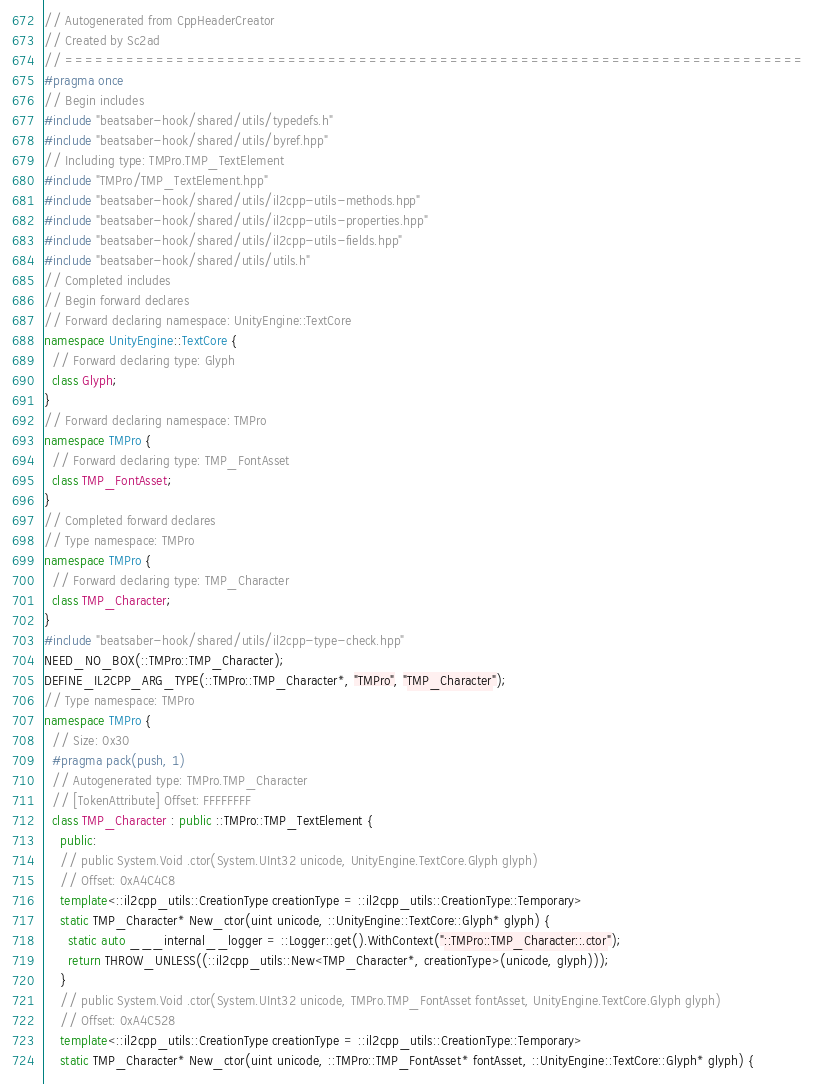Convert code to text. <code><loc_0><loc_0><loc_500><loc_500><_C++_>// Autogenerated from CppHeaderCreator
// Created by Sc2ad
// =========================================================================
#pragma once
// Begin includes
#include "beatsaber-hook/shared/utils/typedefs.h"
#include "beatsaber-hook/shared/utils/byref.hpp"
// Including type: TMPro.TMP_TextElement
#include "TMPro/TMP_TextElement.hpp"
#include "beatsaber-hook/shared/utils/il2cpp-utils-methods.hpp"
#include "beatsaber-hook/shared/utils/il2cpp-utils-properties.hpp"
#include "beatsaber-hook/shared/utils/il2cpp-utils-fields.hpp"
#include "beatsaber-hook/shared/utils/utils.h"
// Completed includes
// Begin forward declares
// Forward declaring namespace: UnityEngine::TextCore
namespace UnityEngine::TextCore {
  // Forward declaring type: Glyph
  class Glyph;
}
// Forward declaring namespace: TMPro
namespace TMPro {
  // Forward declaring type: TMP_FontAsset
  class TMP_FontAsset;
}
// Completed forward declares
// Type namespace: TMPro
namespace TMPro {
  // Forward declaring type: TMP_Character
  class TMP_Character;
}
#include "beatsaber-hook/shared/utils/il2cpp-type-check.hpp"
NEED_NO_BOX(::TMPro::TMP_Character);
DEFINE_IL2CPP_ARG_TYPE(::TMPro::TMP_Character*, "TMPro", "TMP_Character");
// Type namespace: TMPro
namespace TMPro {
  // Size: 0x30
  #pragma pack(push, 1)
  // Autogenerated type: TMPro.TMP_Character
  // [TokenAttribute] Offset: FFFFFFFF
  class TMP_Character : public ::TMPro::TMP_TextElement {
    public:
    // public System.Void .ctor(System.UInt32 unicode, UnityEngine.TextCore.Glyph glyph)
    // Offset: 0xA4C4C8
    template<::il2cpp_utils::CreationType creationType = ::il2cpp_utils::CreationType::Temporary>
    static TMP_Character* New_ctor(uint unicode, ::UnityEngine::TextCore::Glyph* glyph) {
      static auto ___internal__logger = ::Logger::get().WithContext("::TMPro::TMP_Character::.ctor");
      return THROW_UNLESS((::il2cpp_utils::New<TMP_Character*, creationType>(unicode, glyph)));
    }
    // public System.Void .ctor(System.UInt32 unicode, TMPro.TMP_FontAsset fontAsset, UnityEngine.TextCore.Glyph glyph)
    // Offset: 0xA4C528
    template<::il2cpp_utils::CreationType creationType = ::il2cpp_utils::CreationType::Temporary>
    static TMP_Character* New_ctor(uint unicode, ::TMPro::TMP_FontAsset* fontAsset, ::UnityEngine::TextCore::Glyph* glyph) {</code> 